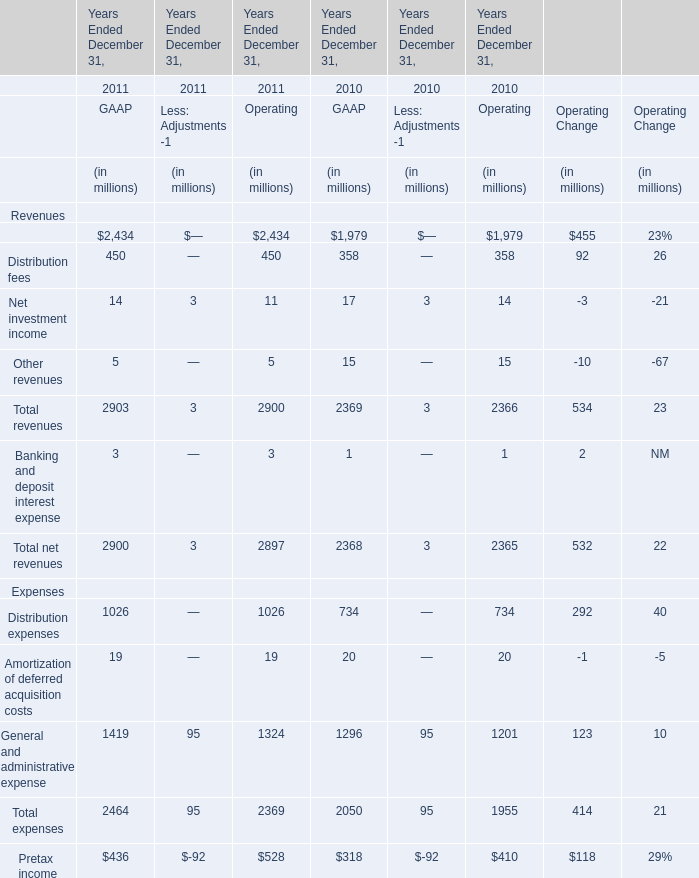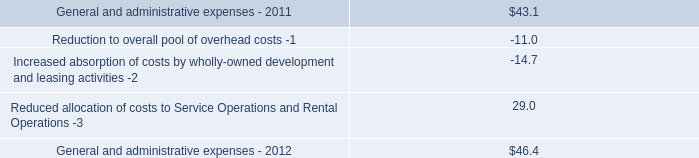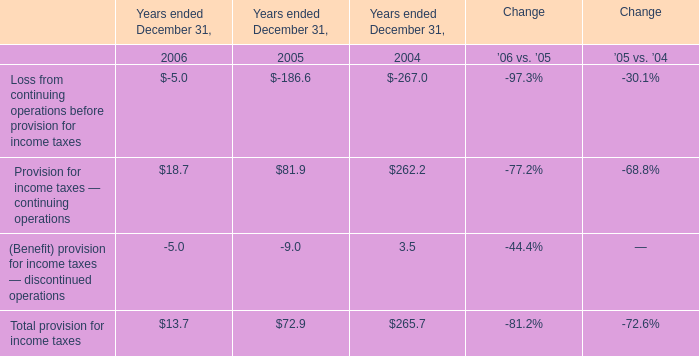What will GAAP's Management and financial advice fees be like in 2012 if it continues to grow at the same rate as it did in 2011? (in million) 
Computations: (2434 * (1 + ((2434 - 1979) / 1979)))
Answer: 2993.61091. 